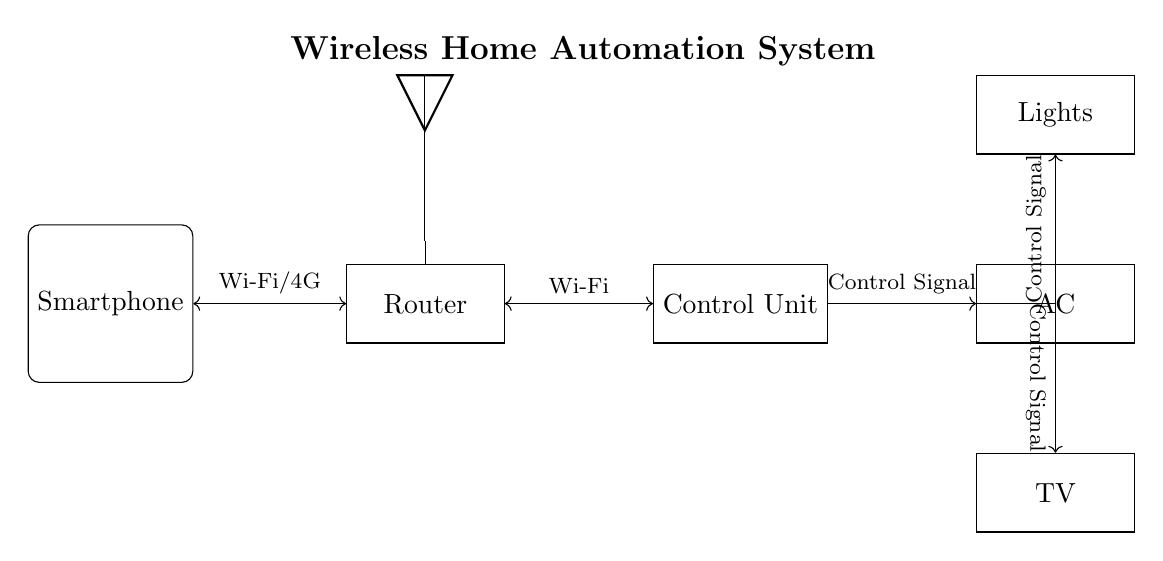What is the main component that connects all devices in the diagram? The router serves as the central hub for the wireless communication, connecting the control unit and the smartphone to the appliances.
Answer: Router What type of signals control the appliances? The diagram indicates that control signals are sent from the control unit to each appliance for operation.
Answer: Control Signal How is the smartphone connected to the system? The smartphone connects to the router via Wi-Fi or 4G, enabling remote control over the system.
Answer: Wi-Fi/4G Which appliances are included in the home automation system? The diagram shows three appliances: Lights, Air Conditioner (AC), and TV, indicating the devices that can be controlled.
Answer: Lights, AC, TV What is the purpose of the central control unit? The central control unit processes the control signals received from the smartphone through the router, enabling the control of the appliances.
Answer: Control appliances What communication technology is used between the router and the control unit? The communication between the router and the central control unit is established using Wi-Fi technology, which allows wireless data transmission.
Answer: Wi-Fi What type of diagram is represented here? This is a circuit diagram illustrating the connections and components of a wireless home automation system for remote control of household appliances.
Answer: Circuit diagram 